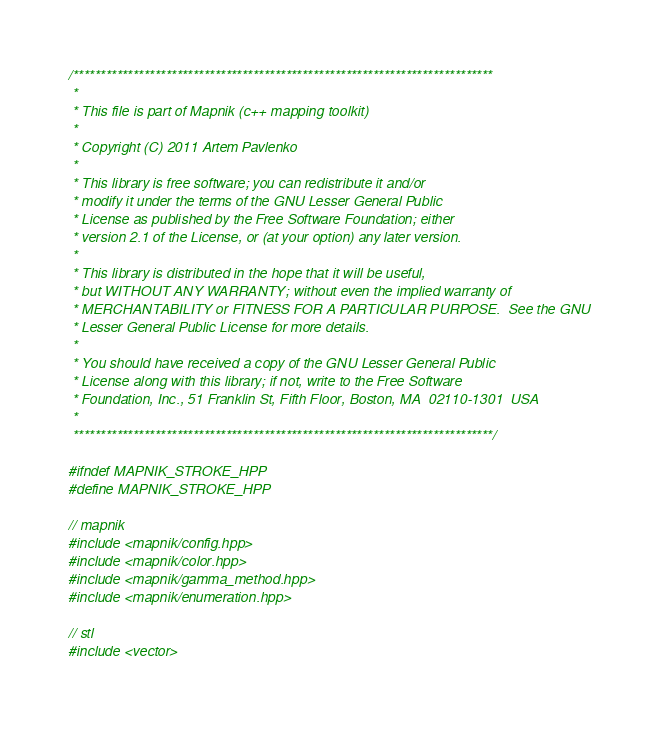Convert code to text. <code><loc_0><loc_0><loc_500><loc_500><_C++_>/*****************************************************************************
 *
 * This file is part of Mapnik (c++ mapping toolkit)
 *
 * Copyright (C) 2011 Artem Pavlenko
 *
 * This library is free software; you can redistribute it and/or
 * modify it under the terms of the GNU Lesser General Public
 * License as published by the Free Software Foundation; either
 * version 2.1 of the License, or (at your option) any later version.
 *
 * This library is distributed in the hope that it will be useful,
 * but WITHOUT ANY WARRANTY; without even the implied warranty of
 * MERCHANTABILITY or FITNESS FOR A PARTICULAR PURPOSE.  See the GNU
 * Lesser General Public License for more details.
 *
 * You should have received a copy of the GNU Lesser General Public
 * License along with this library; if not, write to the Free Software
 * Foundation, Inc., 51 Franklin St, Fifth Floor, Boston, MA  02110-1301  USA
 *
 *****************************************************************************/

#ifndef MAPNIK_STROKE_HPP
#define MAPNIK_STROKE_HPP

// mapnik
#include <mapnik/config.hpp>
#include <mapnik/color.hpp>
#include <mapnik/gamma_method.hpp>
#include <mapnik/enumeration.hpp>

// stl
#include <vector>
</code> 